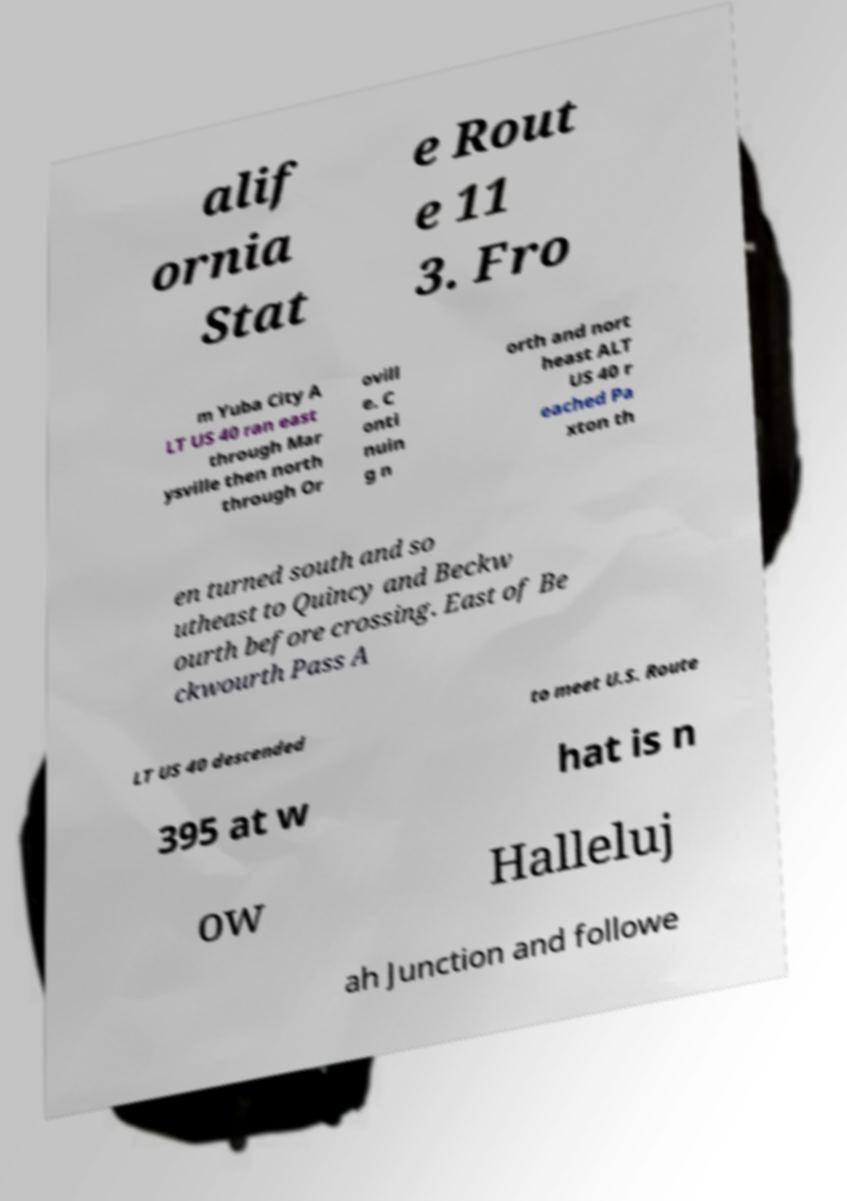What messages or text are displayed in this image? I need them in a readable, typed format. alif ornia Stat e Rout e 11 3. Fro m Yuba City A LT US 40 ran east through Mar ysville then north through Or ovill e. C onti nuin g n orth and nort heast ALT US 40 r eached Pa xton th en turned south and so utheast to Quincy and Beckw ourth before crossing. East of Be ckwourth Pass A LT US 40 descended to meet U.S. Route 395 at w hat is n ow Halleluj ah Junction and followe 